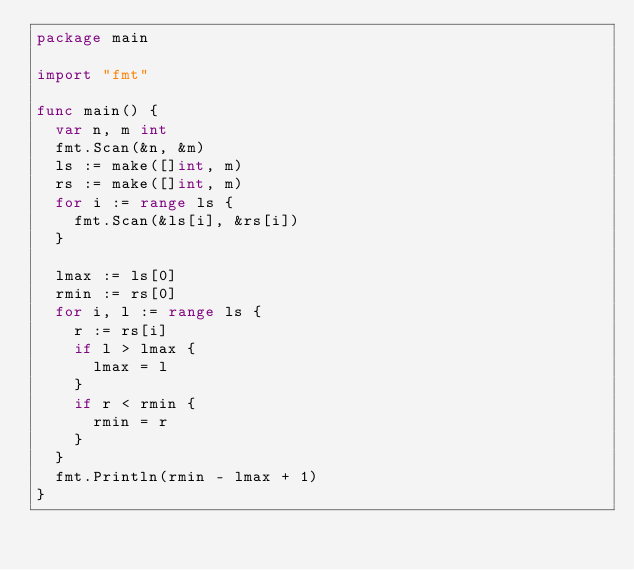<code> <loc_0><loc_0><loc_500><loc_500><_Go_>package main

import "fmt"

func main() {
	var n, m int
	fmt.Scan(&n, &m)
	ls := make([]int, m)
	rs := make([]int, m)
	for i := range ls {
		fmt.Scan(&ls[i], &rs[i])
	}

	lmax := ls[0]
	rmin := rs[0]
	for i, l := range ls {
		r := rs[i]
		if l > lmax {
			lmax = l
		}
		if r < rmin {
			rmin = r
		}
	}
	fmt.Println(rmin - lmax + 1)
}
</code> 